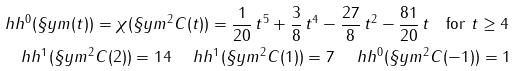Convert formula to latex. <formula><loc_0><loc_0><loc_500><loc_500>& \ h h ^ { 0 } ( \S y m ( t ) ) = \chi ( \S y m ^ { 2 } C ( t ) ) = \frac { 1 } { 2 0 } \, { t } ^ { 5 } + \frac { 3 } { 8 } \, { t } ^ { 4 } - { \frac { 2 7 } { 8 } } \, { t } ^ { 2 } - { \frac { 8 1 } { 2 0 } } \, t \quad \text {for $t\geq 4$} \\ & \quad \ h h ^ { 1 } ( \S y m ^ { 2 } C ( 2 ) ) = 1 4 \quad \ h h ^ { 1 } ( \S y m ^ { 2 } C ( 1 ) ) = 7 \quad \ h h ^ { 0 } ( \S y m ^ { 2 } C ( - 1 ) ) = 1</formula> 